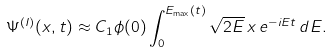<formula> <loc_0><loc_0><loc_500><loc_500>\Psi ^ { ( I ) } ( x , t ) \approx C _ { 1 } \phi ( 0 ) \int _ { 0 } ^ { E _ { \max } ( t ) } \sqrt { 2 E } \, x \, e ^ { - i E t } \, d E .</formula> 